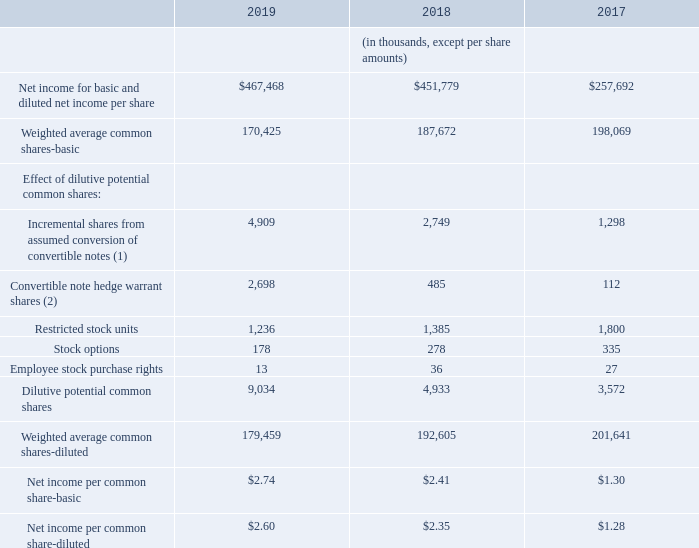N. NET INCOME PER COMMON SHARE
The following table sets forth the computation of basic and diluted net income per common share:
(1) Incremental shares from the assumed conversion of the convertible notes was calculated using the difference between the average Teradyne stock price for the period and the conversion price of $31.62, multiplied by 14.5 million shares. The result of this calculation, representing the total intrinsic value of the convertible debt, was divided by the average Teradyne stock price for the period.
(2) Convertible notes hedge warrant shares were calculated using the difference between the average Teradyne stock price for the period and the warrant price of $39.68, multiplied by 14.5 million shares. The result of this calculation, representing the total intrinsic value of the warrant, was divided by the average Teradyne stock price for the period.
The computation of diluted net income per common share for 2018 excludes the effect of the potential exercise of stock options to purchase approximately 0.1 million shares and restricted stock units to purchase approximately 0.5 million shares because the effect would have been anti-dilutive.
The computation of diluted net income per common share for 2017 excludes the effect of the potential exercise of stock options to purchase approximately 0.1 million shares because the effect would have been antidilutive.
How were the Incremental shares from assumed conversion of convertible notes calculated? Calculated using the difference between the average teradyne stock price for the period and the conversion price of $31.62, multiplied by 14.5 million shares. How were the Convertible note hedge warrant shares calculated? Calculated using the difference between the average teradyne stock price for the period and the warrant price of $39.68, multiplied by 14.5 million shares. In which years was the net income pre common share calculated? 2019, 2018, 2017. In which year were the Employee stock purchase rights the largest? 36>27>13
Answer: 2018. What was the change in Net income per common share-diluted in 2019 from 2018? 2.60-2.35
Answer: 0.25. What was the percentage change in Net income per common share-diluted in 2019 from 2018?
Answer scale should be: percent. (2.60-2.35)/2.35
Answer: 10.64. 